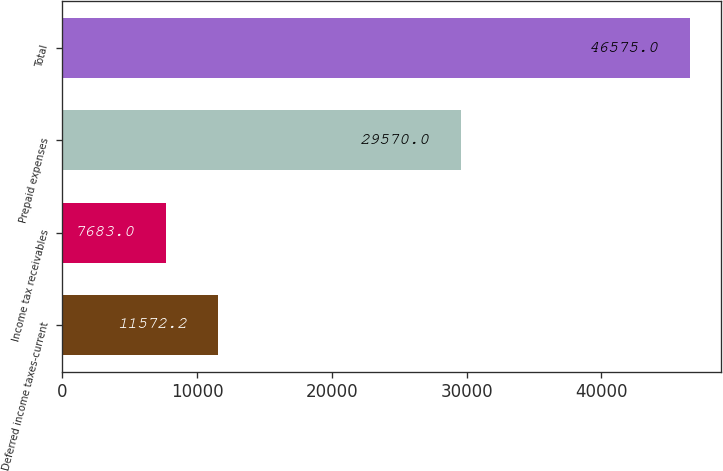Convert chart to OTSL. <chart><loc_0><loc_0><loc_500><loc_500><bar_chart><fcel>Deferred income taxes-current<fcel>Income tax receivables<fcel>Prepaid expenses<fcel>Total<nl><fcel>11572.2<fcel>7683<fcel>29570<fcel>46575<nl></chart> 